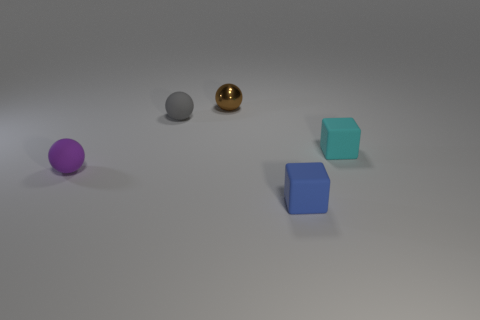The small rubber object that is both in front of the cyan rubber thing and behind the blue rubber block has what shape? The small rubber object positioned between the cyan-colored item in the foreground and the blue block in the background is spherical in shape. This object has a glossy, reflective surface and appears to be a rubber ball due to its round contours and uniform texture. 